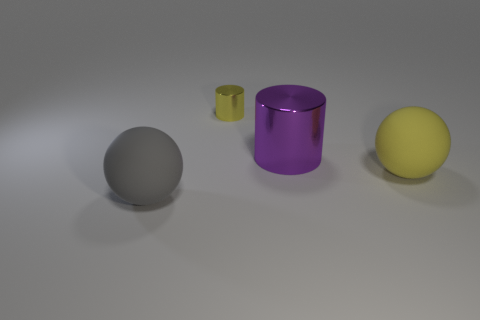What is the size of the object in front of the large yellow rubber sphere?
Offer a very short reply. Large. Is the purple metal cylinder the same size as the yellow cylinder?
Provide a succinct answer. No. Are there fewer yellow shiny objects that are left of the small object than cylinders that are right of the yellow matte thing?
Your answer should be compact. No. What size is the object that is to the left of the purple shiny cylinder and on the right side of the large gray matte object?
Keep it short and to the point. Small. There is a big matte thing that is on the left side of the yellow object in front of the big purple metallic cylinder; is there a matte object on the left side of it?
Keep it short and to the point. No. Are any tiny red metal balls visible?
Provide a short and direct response. No. Are there more big rubber balls behind the small cylinder than purple metal cylinders that are in front of the gray thing?
Ensure brevity in your answer.  No. There is another yellow cylinder that is the same material as the large cylinder; what is its size?
Your answer should be very brief. Small. There is a yellow shiny cylinder left of the matte sphere that is on the right side of the cylinder that is in front of the small object; how big is it?
Offer a very short reply. Small. There is a ball that is to the left of the small yellow metal cylinder; what is its color?
Make the answer very short. Gray. 